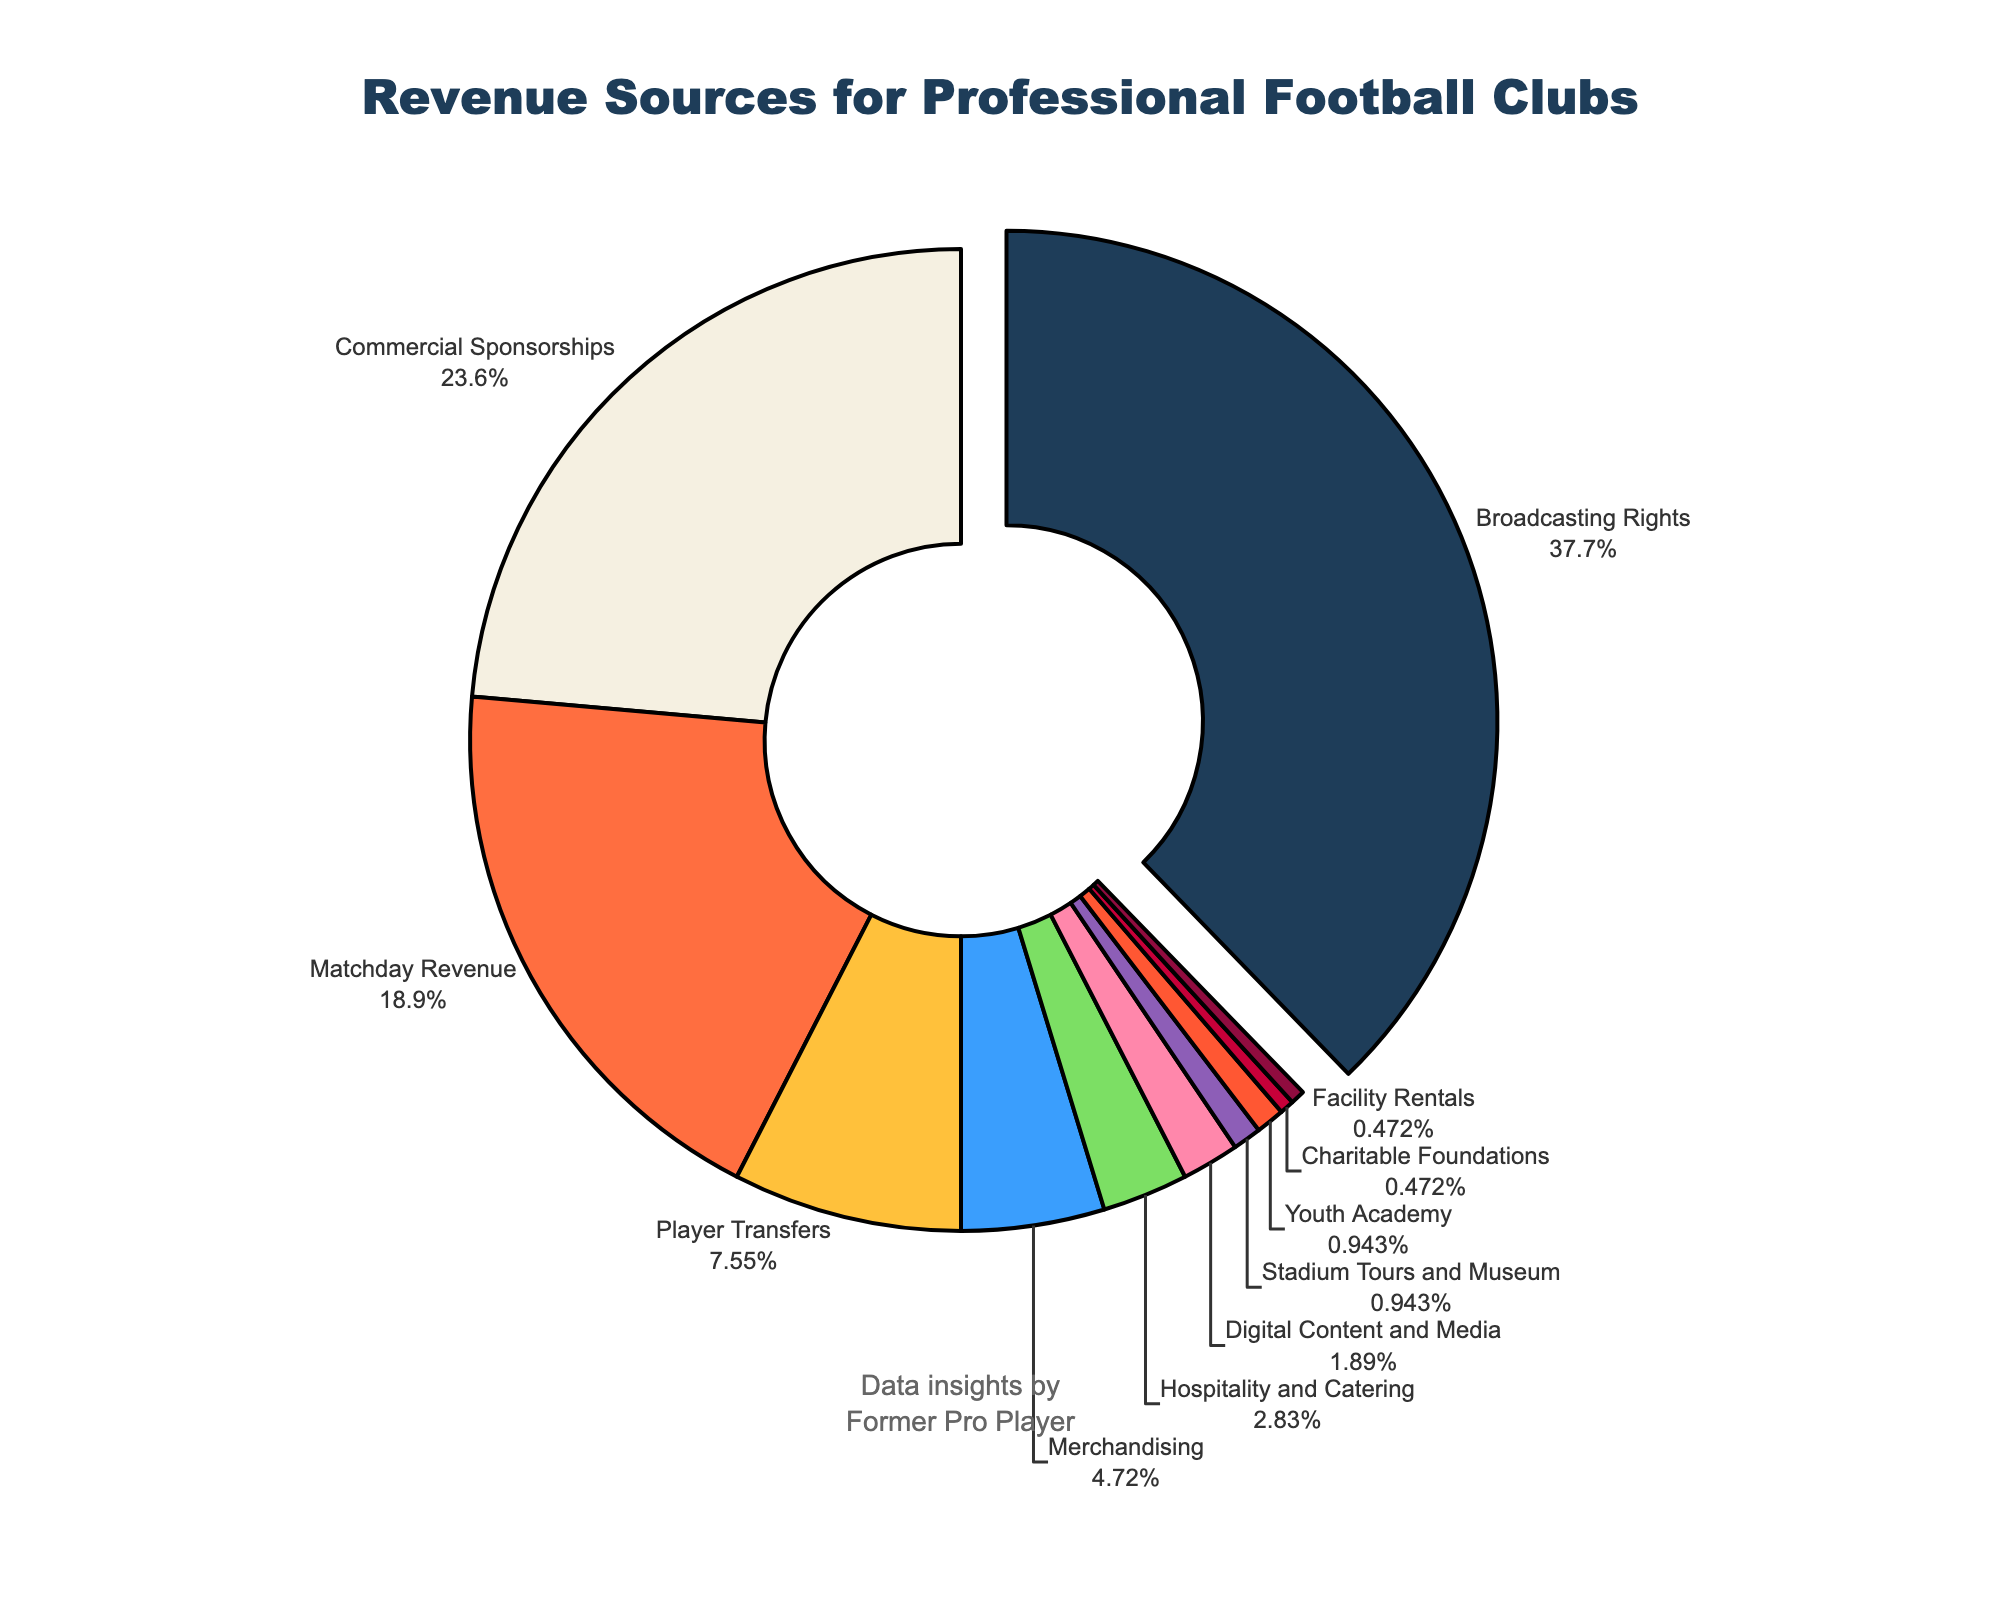What's the largest revenue source for professional football clubs? The pie chart clearly shows that Broadcasting Rights make up the largest portion of the chart, accounting for 40% of the total revenue.
Answer: Broadcasting Rights What's the combined percentage of the two smallest revenue sources? The smallest revenue sources are Charitable Foundations and Facility Rentals, each contributing 0.5%. Adding these together gives 0.5 + 0.5 = 1%.
Answer: 1% Which revenue source contributes more: Commercial Sponsorships or Player Transfers? Comparing the slices, Commercial Sponsorships contribute 25%, while Player Transfers contribute 8%. Therefore, Commercial Sponsorships contribute more.
Answer: Commercial Sponsorships How much more percentage does Matchday Revenue contribute compared to Merchandising? Matchday Revenue contributes 20%, while Merchandising contributes 5%. The difference is 20% - 5% = 15%.
Answer: 15% What is the total percentage for revenue sources that contribute more than 5%? The revenue sources contributing more than 5% are Matchday Revenue (20%), Broadcasting Rights (40%), and Commercial Sponsorships (25%). Summing these gives: 20 + 40 + 25 = 85%.
Answer: 85% Which revenue source has the third highest contribution? The third largest segment in the pie chart is Commercial Sponsorships, which contribute 25%.
Answer: Commercial Sponsorships What’s the total percentage of revenue sources less than or equal to 2%? Revenue sources with ≤2% are Youth Academy (1%), Digital Content and Media (2%), Charitable Foundations (0.5%), Facility Rentals (0.5%), and Stadium Tours and Museum (1%). Adding these gives: 1 + 2 + 0.5 + 0.5 + 1 = 5%.
Answer: 5% Is the percentage of Player Transfers more than Merchandising plus Hospitality and Catering? Player Transfers contribute 8%. Merchandising plus Hospitality and Catering contribute 5% + 3% = 8%. They are equal.
Answer: No Which color represents the largest revenue source? The largest revenue source, Broadcasting Rights, is represented by the color corresponding to its slice, which is typically evident in the visual legend or the segment color in the pie chart. Based on the sorted data and colors used, Broadcasting Rights should correspond to the second color.
Answer: Light Beige (Assumed based on sequence) Compare the combined contributions of Digital Content and Media, Charitable Foundations, and Facility Rentals to Matchday Revenue. Digital Content and Media: 2%, Charitable Foundations: 0.5%, Facility Rentals: 0.5%. Combined = 2 + 0.5 + 0.5 = 3%. Matchday Revenue contributes 20%. Therefore, Matchday Revenue is significantly higher.
Answer: Matchday Revenue 